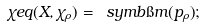<formula> <loc_0><loc_0><loc_500><loc_500>\chi e q ( X , \chi _ { \rho } ) = \ s y m b { \i m ( p _ { \rho } ) } ;</formula> 